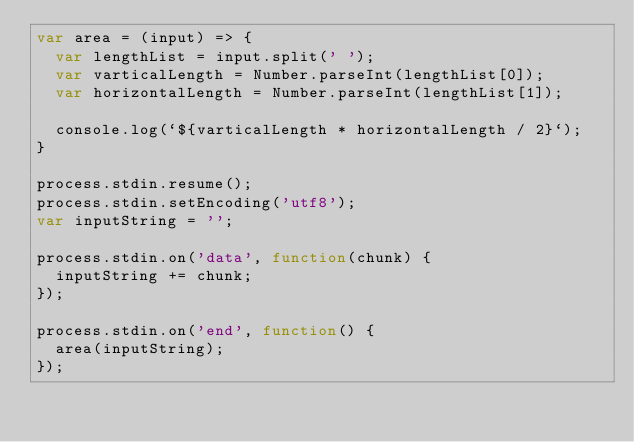Convert code to text. <code><loc_0><loc_0><loc_500><loc_500><_JavaScript_>var area = (input) => {
  var lengthList = input.split(' ');
  var varticalLength = Number.parseInt(lengthList[0]);
  var horizontalLength = Number.parseInt(lengthList[1]);
  
  console.log(`${varticalLength * horizontalLength / 2}`);
}

process.stdin.resume();
process.stdin.setEncoding('utf8');
var inputString = '';

process.stdin.on('data', function(chunk) {
  inputString += chunk;
});

process.stdin.on('end', function() {
  area(inputString);
});</code> 